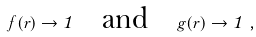Convert formula to latex. <formula><loc_0><loc_0><loc_500><loc_500>f ( r ) \to 1 \quad { \text {and} } \quad g ( r ) \to 1 \ ,</formula> 